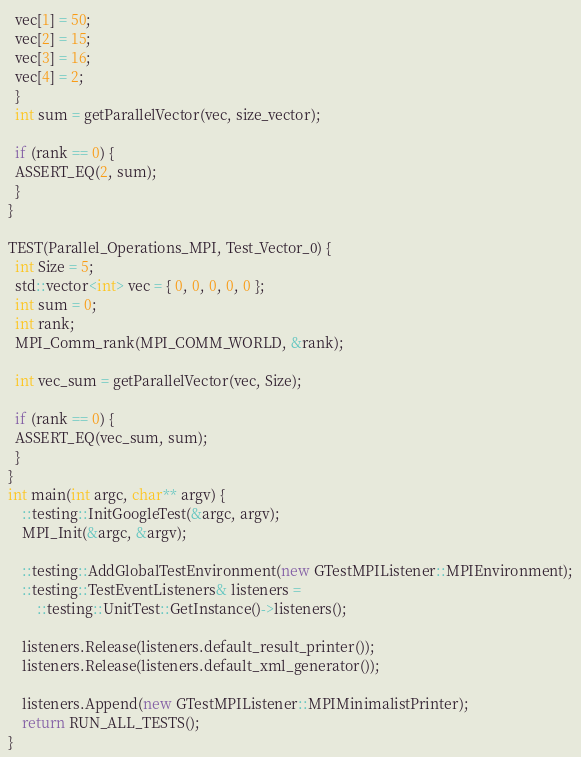<code> <loc_0><loc_0><loc_500><loc_500><_C++_>  vec[1] = 50;
  vec[2] = 15;
  vec[3] = 16;
  vec[4] = 2;
  }
  int sum = getParallelVector(vec, size_vector);

  if (rank == 0) {
  ASSERT_EQ(2, sum);
  }
}

TEST(Parallel_Operations_MPI, Test_Vector_0) {
  int Size = 5;
  std::vector<int> vec = { 0, 0, 0, 0, 0 };
  int sum = 0;
  int rank;
  MPI_Comm_rank(MPI_COMM_WORLD, &rank);

  int vec_sum = getParallelVector(vec, Size);

  if (rank == 0) {
  ASSERT_EQ(vec_sum, sum);
  }
}
int main(int argc, char** argv) {
    ::testing::InitGoogleTest(&argc, argv);
    MPI_Init(&argc, &argv);

    ::testing::AddGlobalTestEnvironment(new GTestMPIListener::MPIEnvironment);
    ::testing::TestEventListeners& listeners =
        ::testing::UnitTest::GetInstance()->listeners();

    listeners.Release(listeners.default_result_printer());
    listeners.Release(listeners.default_xml_generator());

    listeners.Append(new GTestMPIListener::MPIMinimalistPrinter);
    return RUN_ALL_TESTS();
}
</code> 